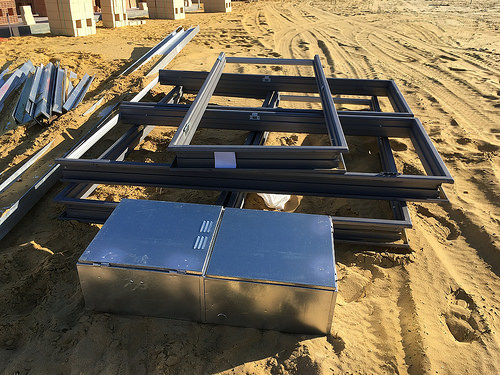<image>
Can you confirm if the frames is on the sand? Yes. Looking at the image, I can see the frames is positioned on top of the sand, with the sand providing support. Is there a frame on the sand? Yes. Looking at the image, I can see the frame is positioned on top of the sand, with the sand providing support. 